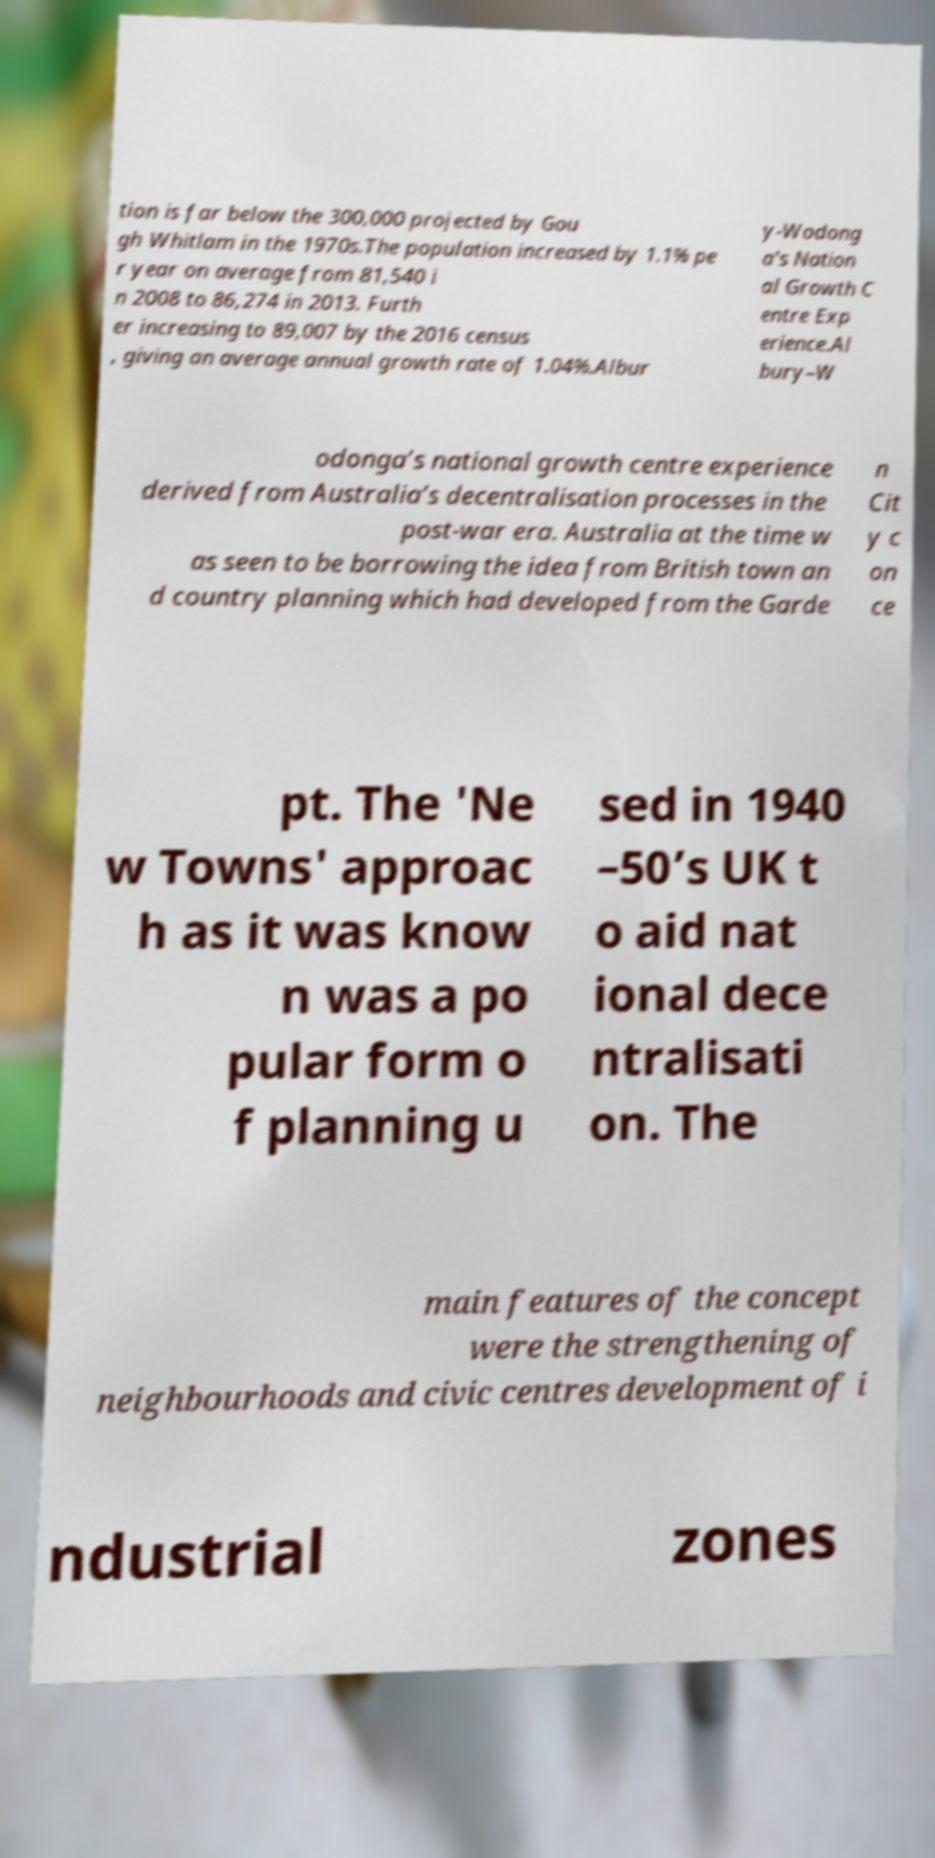Could you extract and type out the text from this image? tion is far below the 300,000 projected by Gou gh Whitlam in the 1970s.The population increased by 1.1% pe r year on average from 81,540 i n 2008 to 86,274 in 2013. Furth er increasing to 89,007 by the 2016 census , giving an average annual growth rate of 1.04%.Albur y-Wodong a's Nation al Growth C entre Exp erience.Al bury–W odonga’s national growth centre experience derived from Australia’s decentralisation processes in the post-war era. Australia at the time w as seen to be borrowing the idea from British town an d country planning which had developed from the Garde n Cit y c on ce pt. The 'Ne w Towns' approac h as it was know n was a po pular form o f planning u sed in 1940 –50’s UK t o aid nat ional dece ntralisati on. The main features of the concept were the strengthening of neighbourhoods and civic centres development of i ndustrial zones 